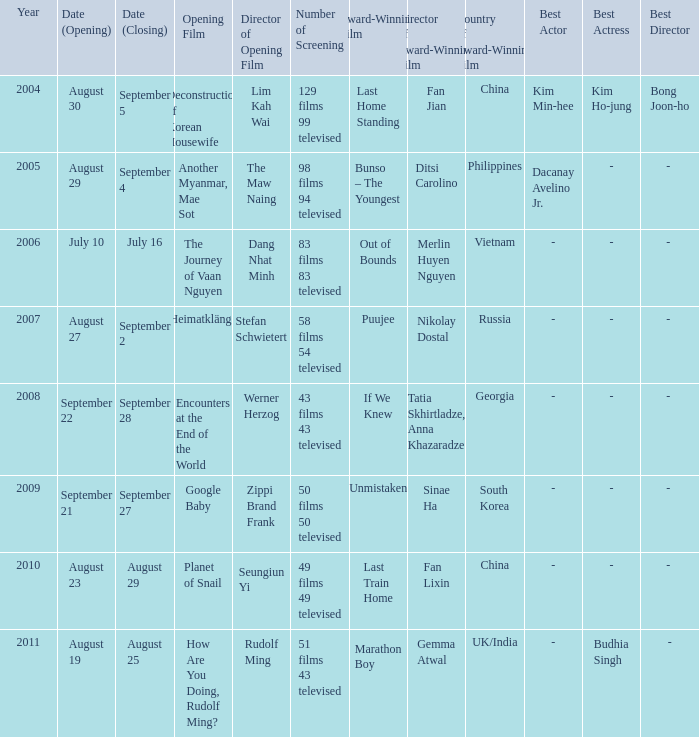Which prize-winning movie has a display count of 50 films 50 broadcasted? Unmistaken. 